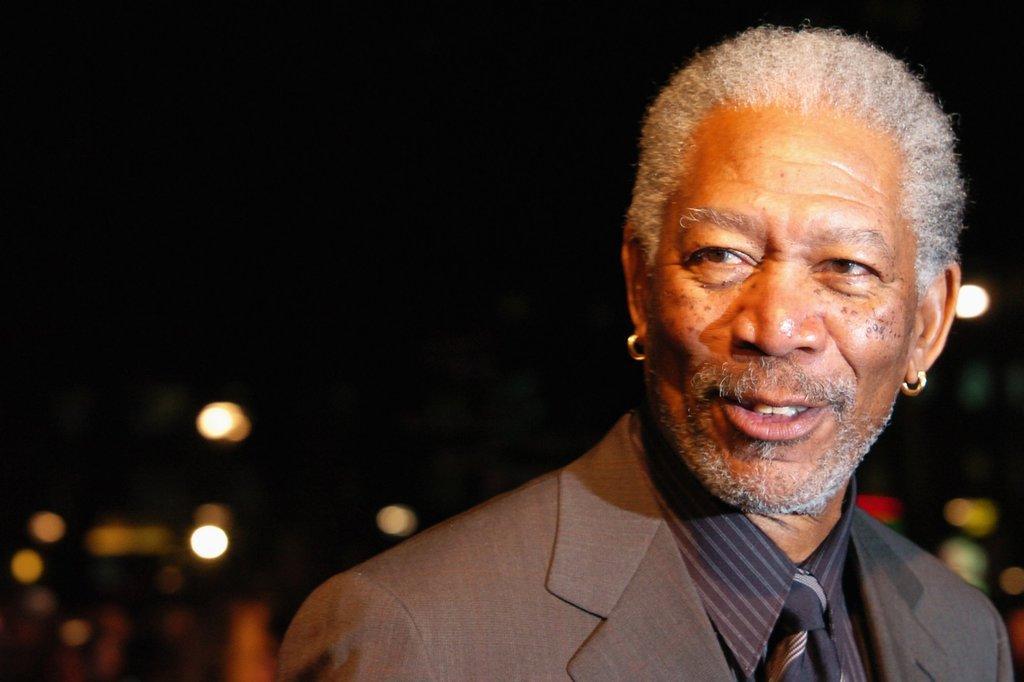In one or two sentences, can you explain what this image depicts? In this picture there is a person with brown suit is smiling and he is wearing earrings. At the back the image is blurry. At the top there is sky. 